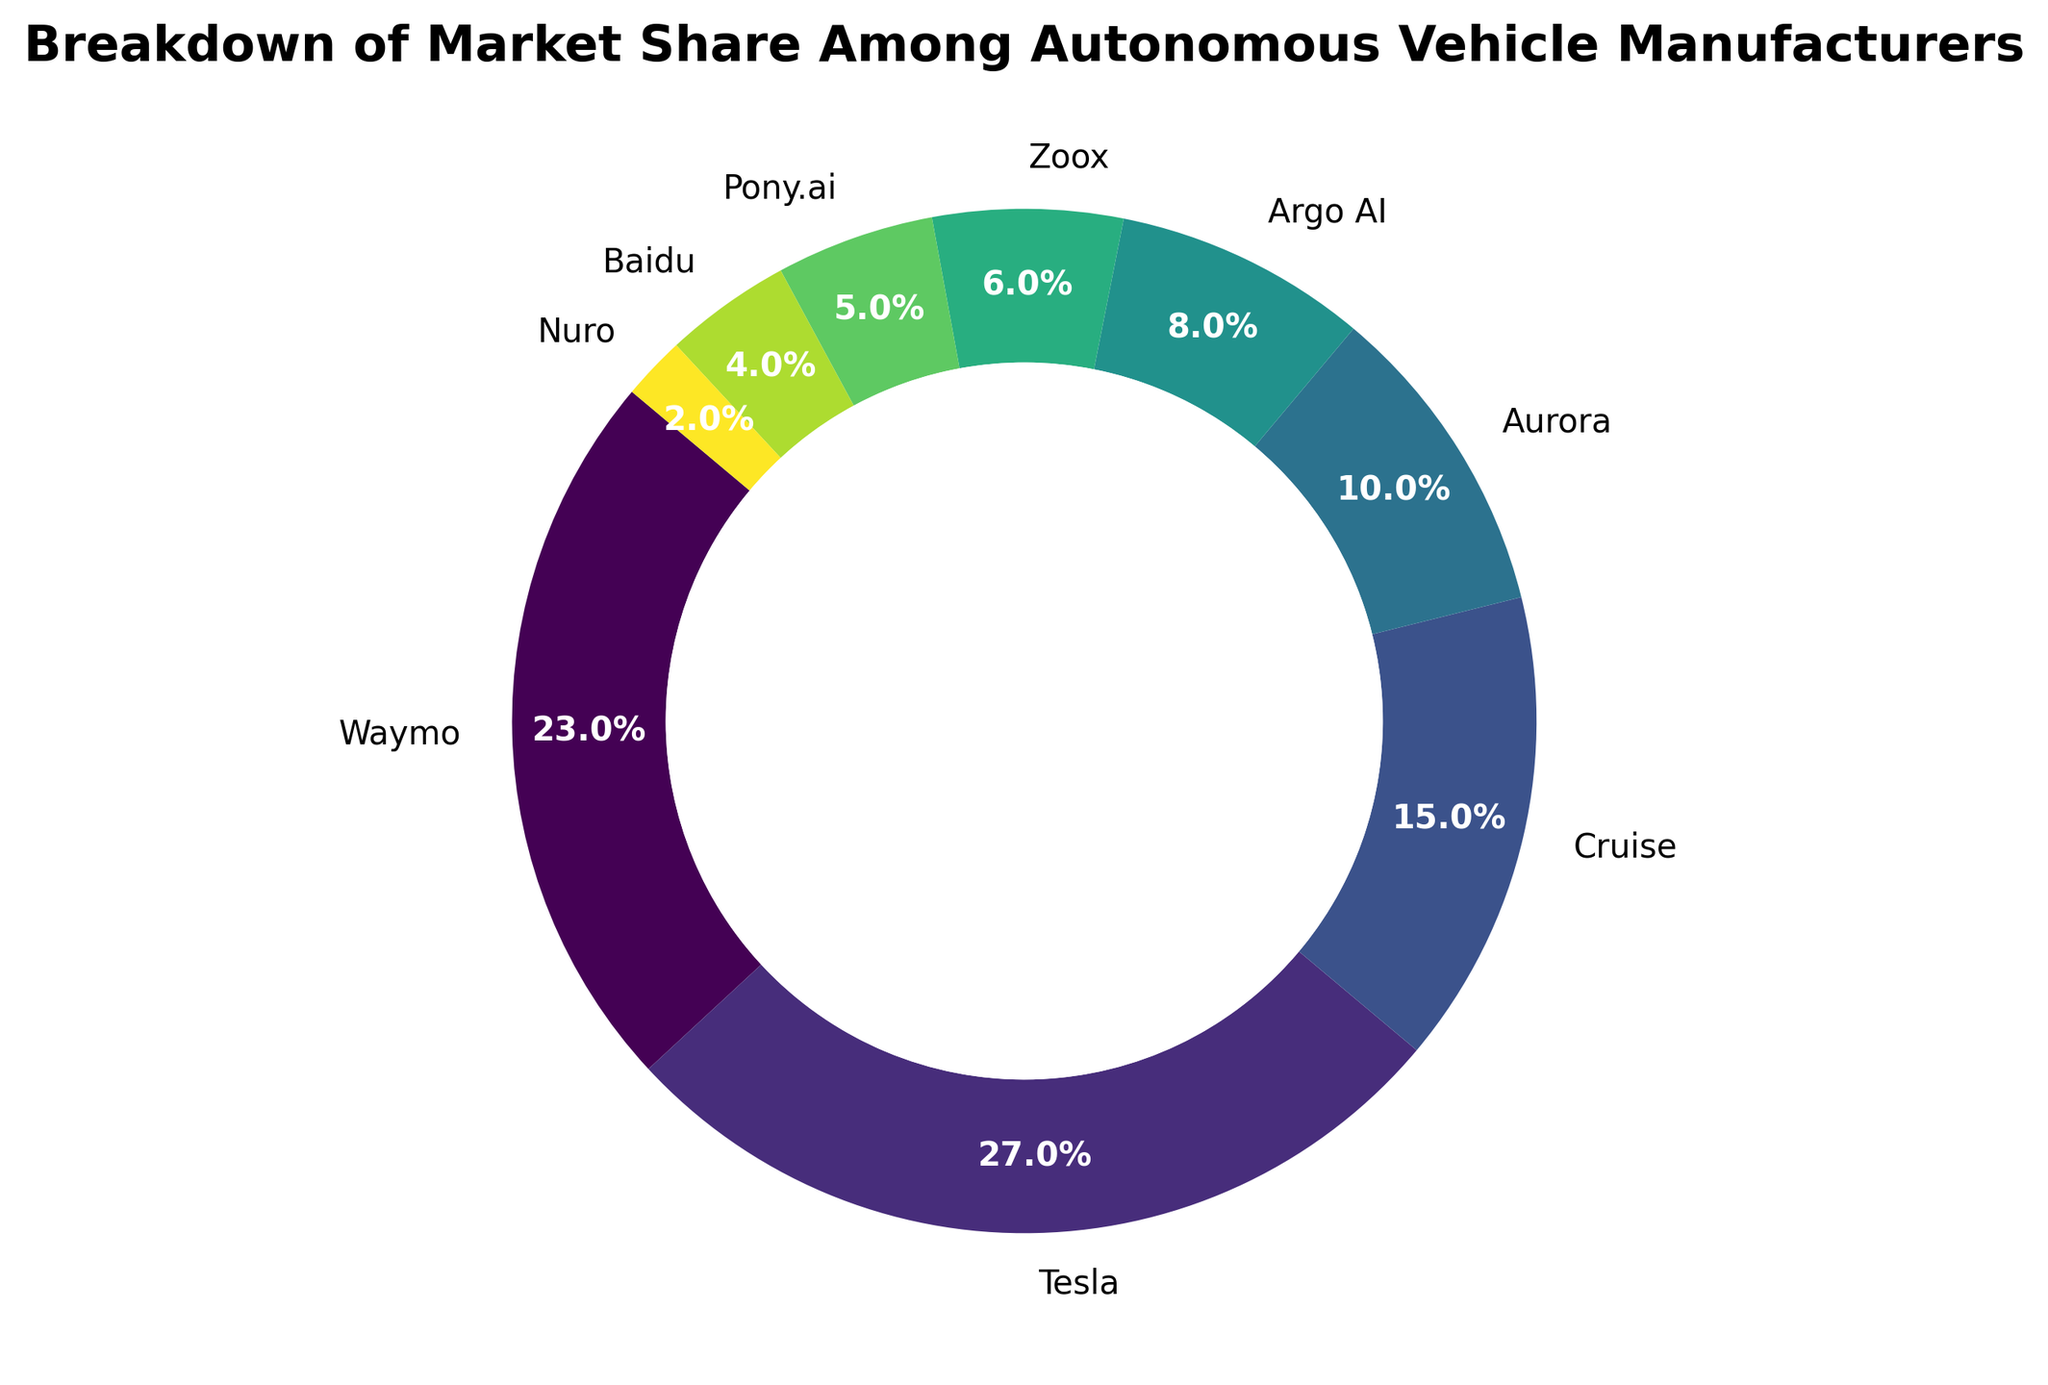What is the total market share of the top three manufacturers? The top three manufacturers are Tesla (27%), Waymo (23%), and Cruise (15%). Summing their market shares, we get 27 + 23 + 15 = 65%.
Answer: 65% Which manufacturer has the smallest market share? By examining the chart, we can see that Nuro has the smallest segment, representing 2% of the market share.
Answer: Nuro How much more market share does Tesla have compared to Pony.ai? Tesla has a market share of 27%, while Pony.ai has a market share of 5%. The difference is calculated as 27 - 5 = 22%.
Answer: 22% Which manufacturers have a market share greater than 10%? The manufacturers with market shares greater than 10% are Tesla (27%), Waymo (23%), and Cruise (15%), and Aurora (10%).
Answer: Tesla, Waymo, Cruise, Aurora What is the combined market share of Argo AI, Zoox, and Baidu? The market shares are 8% for Argo AI, 6% for Zoox, and 4% for Baidu. Adding these values together results in 8 + 6 + 4 = 18%.
Answer: 18% Rank the manufacturers by their market share from highest to lowest. Observing the chart, the rankings are: 1) Tesla (27%), 2) Waymo (23%), 3) Cruise (15%), 4) Aurora (10%), 5) Argo AI (8%), 6) Zoox (6%), 7) Pony.ai (5%), 8) Baidu (4%), 9) Nuro (2%).
Answer: Tesla, Waymo, Cruise, Aurora, Argo AI, Zoox, Pony.ai, Baidu, Nuro What is the percentage difference in market share between the top manufacturer and the smallest manufacturer? Tesla has a market share of 27% and Nuro has 2%. The percentage difference is calculated as (27 - 2) / 2 * 100 = 1250%.
Answer: 1250% What is the visual indicator used to emphasize the market share divisions in the ring chart? The market share divisions are emphasized using different colors for each manufacturer's segment in the ring chart. A central white circle is also used to create the ring effect.
Answer: Different colors and central white circle 